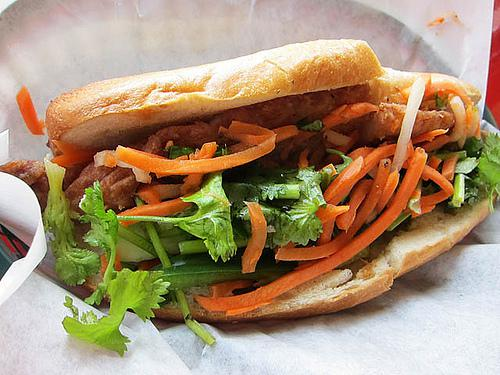Question: what is shown in the photo?
Choices:
A. Dogs playing.
B. Cats cuddling.
C. Food.
D. Men working.
Answer with the letter. Answer: C Question: where is the sandwich?
Choices:
A. On the table.
B. On the counter.
C. In the trash can.
D. On a plate.
Answer with the letter. Answer: D Question: what type of food is shown?
Choices:
A. A sandwich.
B. Bananas.
C. Chicken bowl.
D. Apples.
Answer with the letter. Answer: A Question: what vegetables are visible?
Choices:
A. Carrot.
B. Cauliflower.
C. Broccoli.
D. Green beans.
Answer with the letter. Answer: A Question: what colors are the sandwich?
Choices:
A. Red and brown.
B. Yellow, white, and grey.
C. Blue, white, and brown.
D. Green, orange and brown.
Answer with the letter. Answer: D 